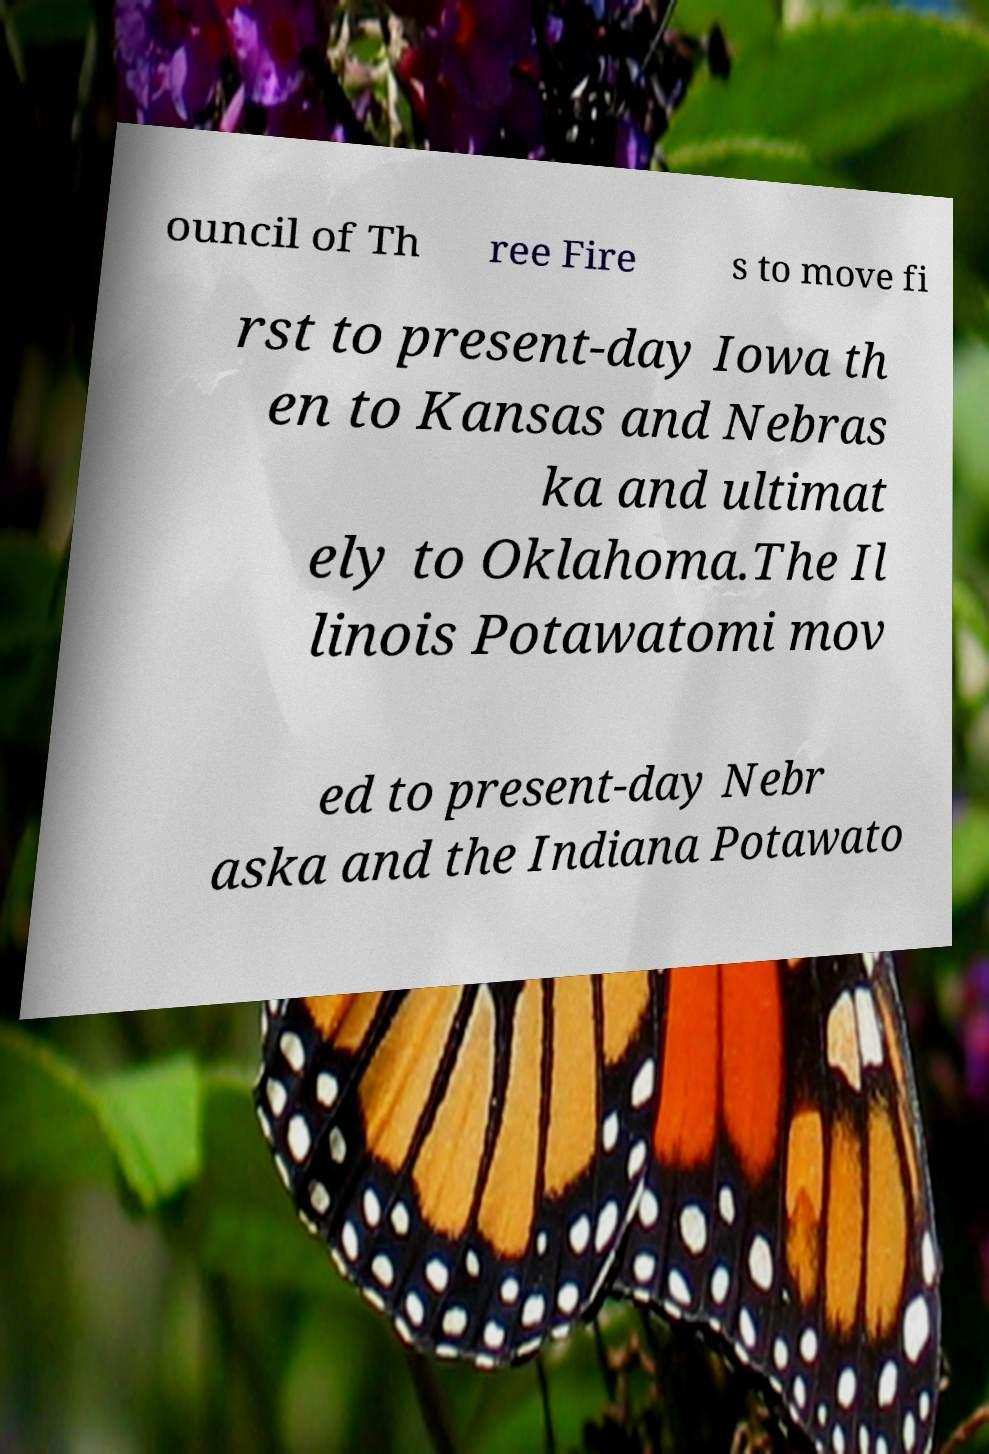What messages or text are displayed in this image? I need them in a readable, typed format. ouncil of Th ree Fire s to move fi rst to present-day Iowa th en to Kansas and Nebras ka and ultimat ely to Oklahoma.The Il linois Potawatomi mov ed to present-day Nebr aska and the Indiana Potawato 